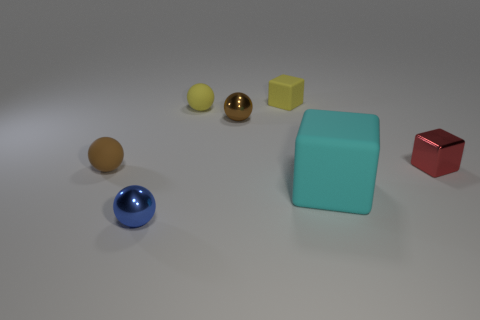Are there any tiny metallic blocks?
Give a very brief answer. Yes. What number of objects are small things in front of the tiny yellow matte block or things on the left side of the yellow cube?
Offer a very short reply. 5. Is the color of the big matte cube the same as the metal block?
Offer a terse response. No. Is the number of yellow cubes less than the number of purple rubber objects?
Give a very brief answer. No. Are there any blocks in front of the big object?
Offer a terse response. No. Does the small yellow block have the same material as the small red object?
Ensure brevity in your answer.  No. The other tiny object that is the same shape as the red thing is what color?
Keep it short and to the point. Yellow. Is the color of the matte sphere in front of the tiny brown metallic ball the same as the tiny rubber block?
Provide a short and direct response. No. What shape is the small thing that is the same color as the tiny rubber cube?
Offer a terse response. Sphere. What number of red blocks are the same material as the yellow sphere?
Provide a succinct answer. 0. 